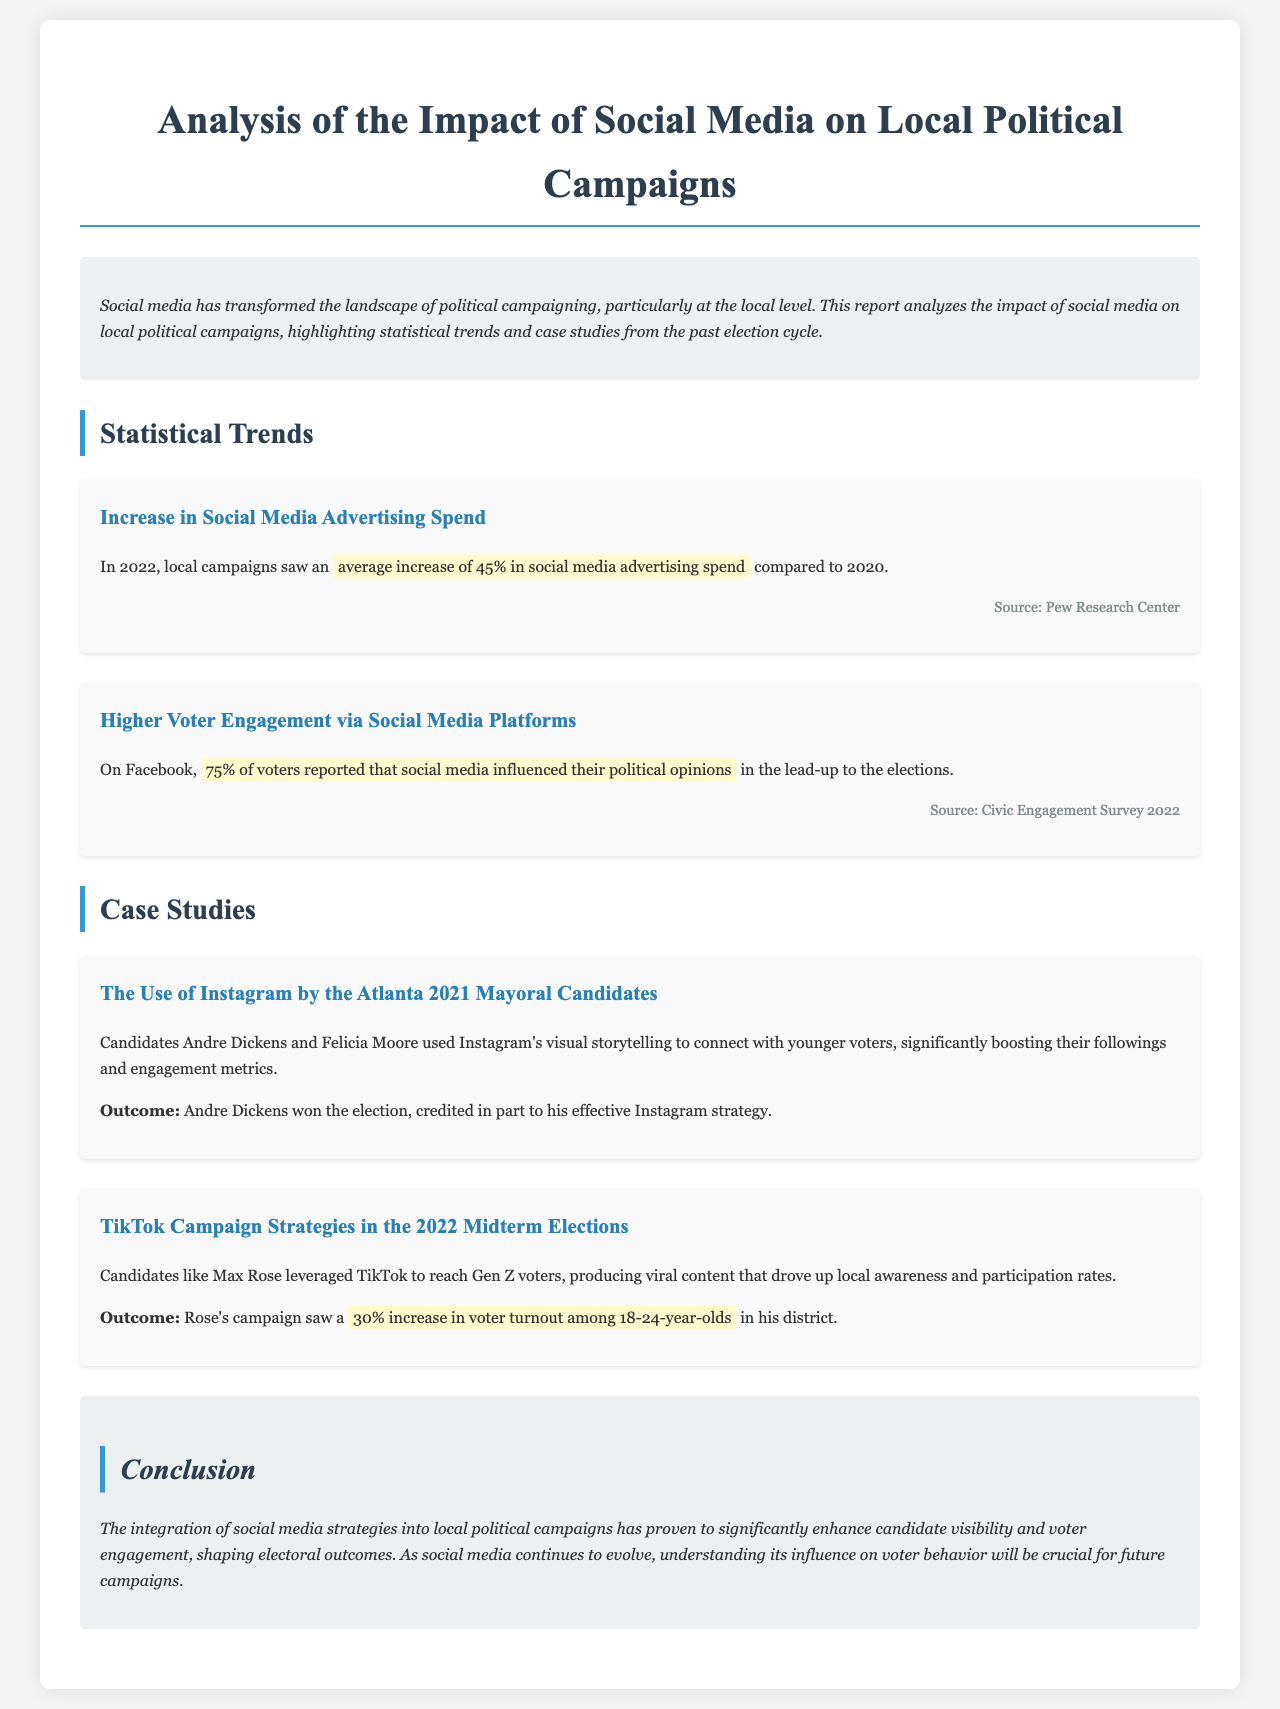What is the title of the report? The title is prominently displayed at the top of the document.
Answer: Analysis of the Impact of Social Media on Local Political Campaigns What was the average increase in social media advertising spend in 2022? The document specifies this increase in the section discussing statistical trends.
Answer: 45% What percentage of voters reported that social media influenced their political opinions on Facebook? This percentage is mentioned in the voter engagement statistics.
Answer: 75% Who were the candidates in the Atlanta 2021 Mayoral election case study? The report provides the names of candidates when discussing the case study.
Answer: Andre Dickens and Felicia Moore What platform did Max Rose leverage for his campaign strategy? The document details which social media platform was used in the case study about Max Rose.
Answer: TikTok What was the voter turnout increase among 18-24-year-olds for Max Rose's campaign? The specific increase is highlighted in the case study section.
Answer: 30% What does the conclusion suggest about the role of social media in electoral outcomes? The conclusion summarizes the overall findings and insights from the report.
Answer: Significantly enhance candidate visibility and voter engagement What year was the Civic Engagement Survey cited in the document? The document mentions the year of the survey in the statistical trends section.
Answer: 2022 What strategy did Andre Dickens use effectively in his campaign? The report describes the strategy used by Andre Dickens in the Atlanta case study.
Answer: Instagram's visual storytelling 